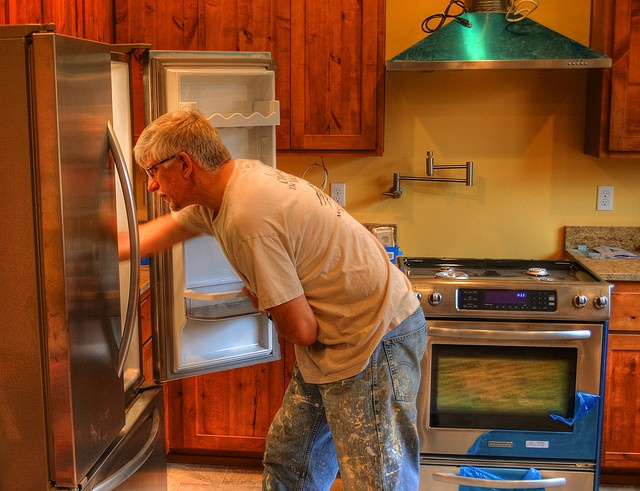Describe the objects in this image and their specific colors. I can see refrigerator in red, maroon, and brown tones, people in red, brown, tan, and maroon tones, oven in red, black, olive, and gray tones, and clock in red, navy, darkblue, blue, and purple tones in this image. 